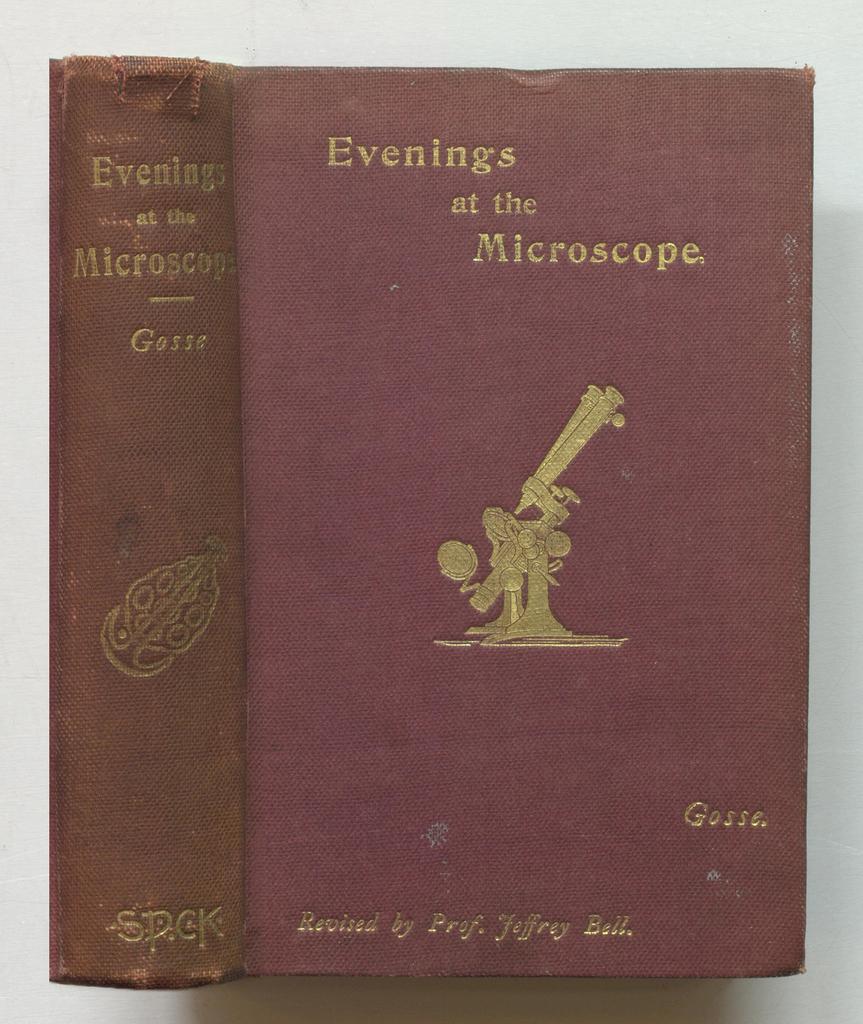Could you give a brief overview of what you see in this image? In this image we can see a book with image and text on it, also the background is white in color. 